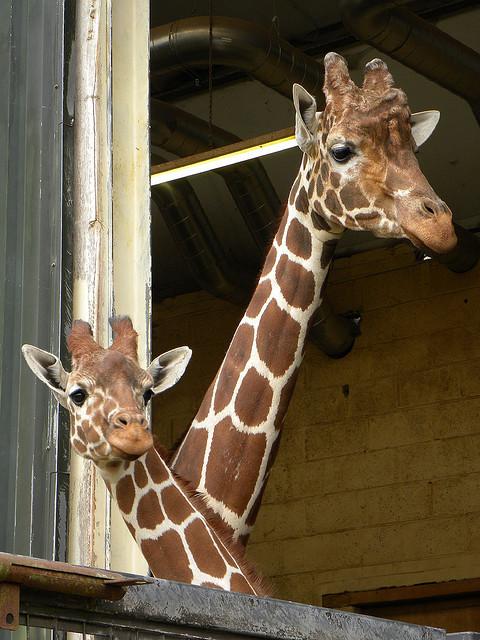In which direction are the animals looking?
Short answer required. Left. What are these giraffes doing?
Be succinct. Looking. How many animals are shown?
Short answer required. 2. 